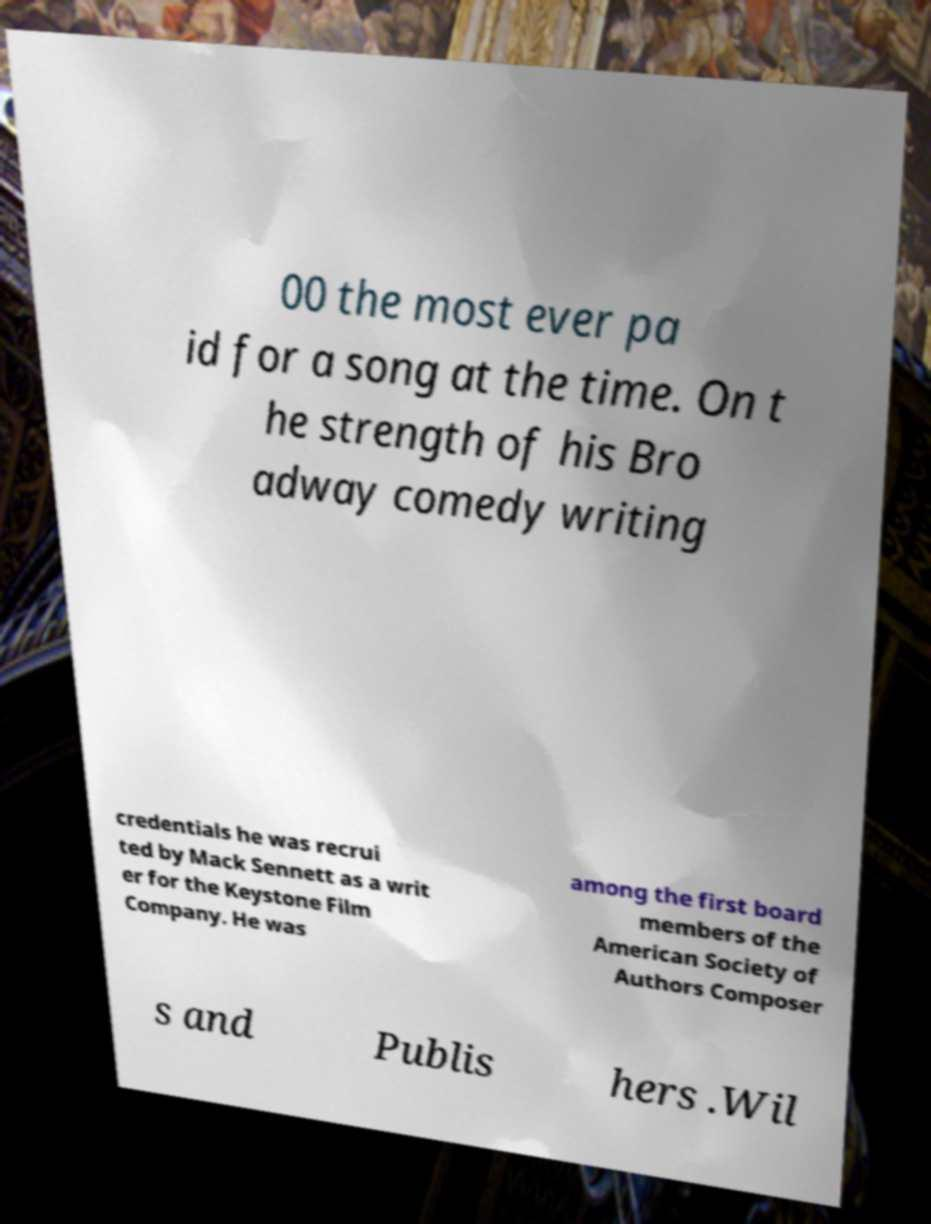There's text embedded in this image that I need extracted. Can you transcribe it verbatim? 00 the most ever pa id for a song at the time. On t he strength of his Bro adway comedy writing credentials he was recrui ted by Mack Sennett as a writ er for the Keystone Film Company. He was among the first board members of the American Society of Authors Composer s and Publis hers .Wil 